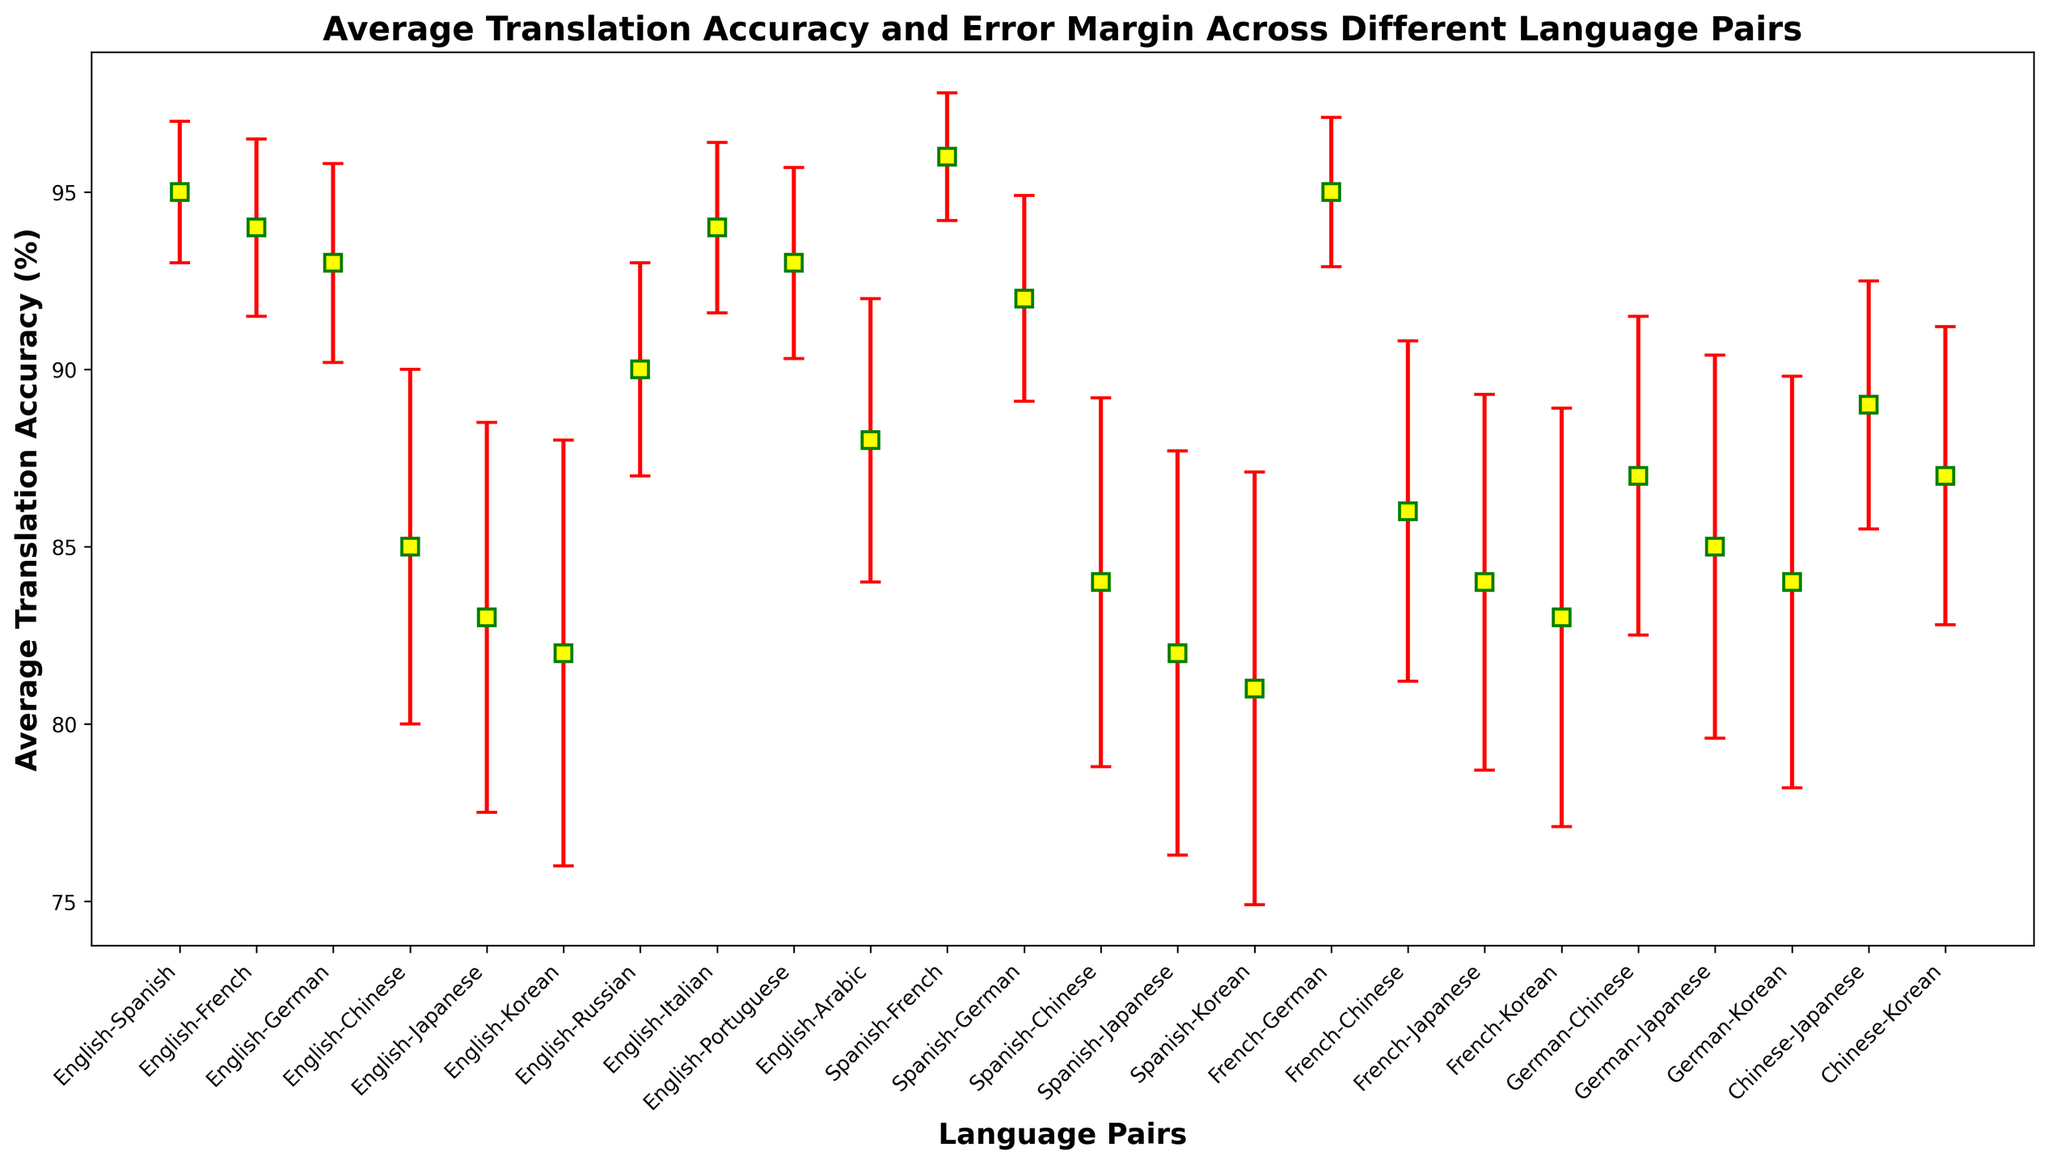Which language pair has the highest average translation accuracy? The language pair with the highest point on the vertical axis signifies the highest average translation accuracy.
Answer: Spanish-French What is the average translation accuracy for the English-Japanese language pair? Locate the English-Japanese label on the horizontal axis and observe the plotted point's position on the vertical axis.
Answer: 83% Which language pair shows the largest error margin? The largest error margin will have the longest red error bar corresponding to its data point.
Answer: English-Korean Compare the average translation accuracies between the English-German and French-Chinese pairs. Which is higher? Observe the vertical positions of the points representing English-German and French-Chinese.
Answer: English-German Which language pair has the smallest error margin? Identify the shortest red error bar among all the plotted points.
Answer: Spanish-French Which has a higher average translation accuracy, English-Russian or Chinese-Japanese? Compare the vertical heights of the points representing English-Russian and Chinese-Japanese.
Answer: English-Russian What is the average of the translations accuracies for the language pairs involving German? Sum the accuracies for English-German, Spanish-German, French-German, German-Chinese, German-Japanese, and German-Korean, then divide by 6. (93 + 92 + 95 + 87 + 85 + 84) / 6
Answer: 89.3% Between English-Korean and French-Korean, which has a higher error margin? Compare the lengths of the red error bars for English-Korean and French-Korean.
Answer: English-Korean Calculate the difference in average translation accuracy between English-Chinese and Spanish-Chinese. Subtract the average translation accuracy of Spanish-Chinese from English-Chinese.
Answer: 1% (85% - 84%) What is the sum of the error margins for the language pairs involving Japanese? Add the error margins of English-Japanese, Spanish-Japanese, French-Japanese, German-Japanese, and Chinese-Japanese. (5.5 + 5.7 + 5.3 + 5.4 + 3.5)
Answer: 25.4% 